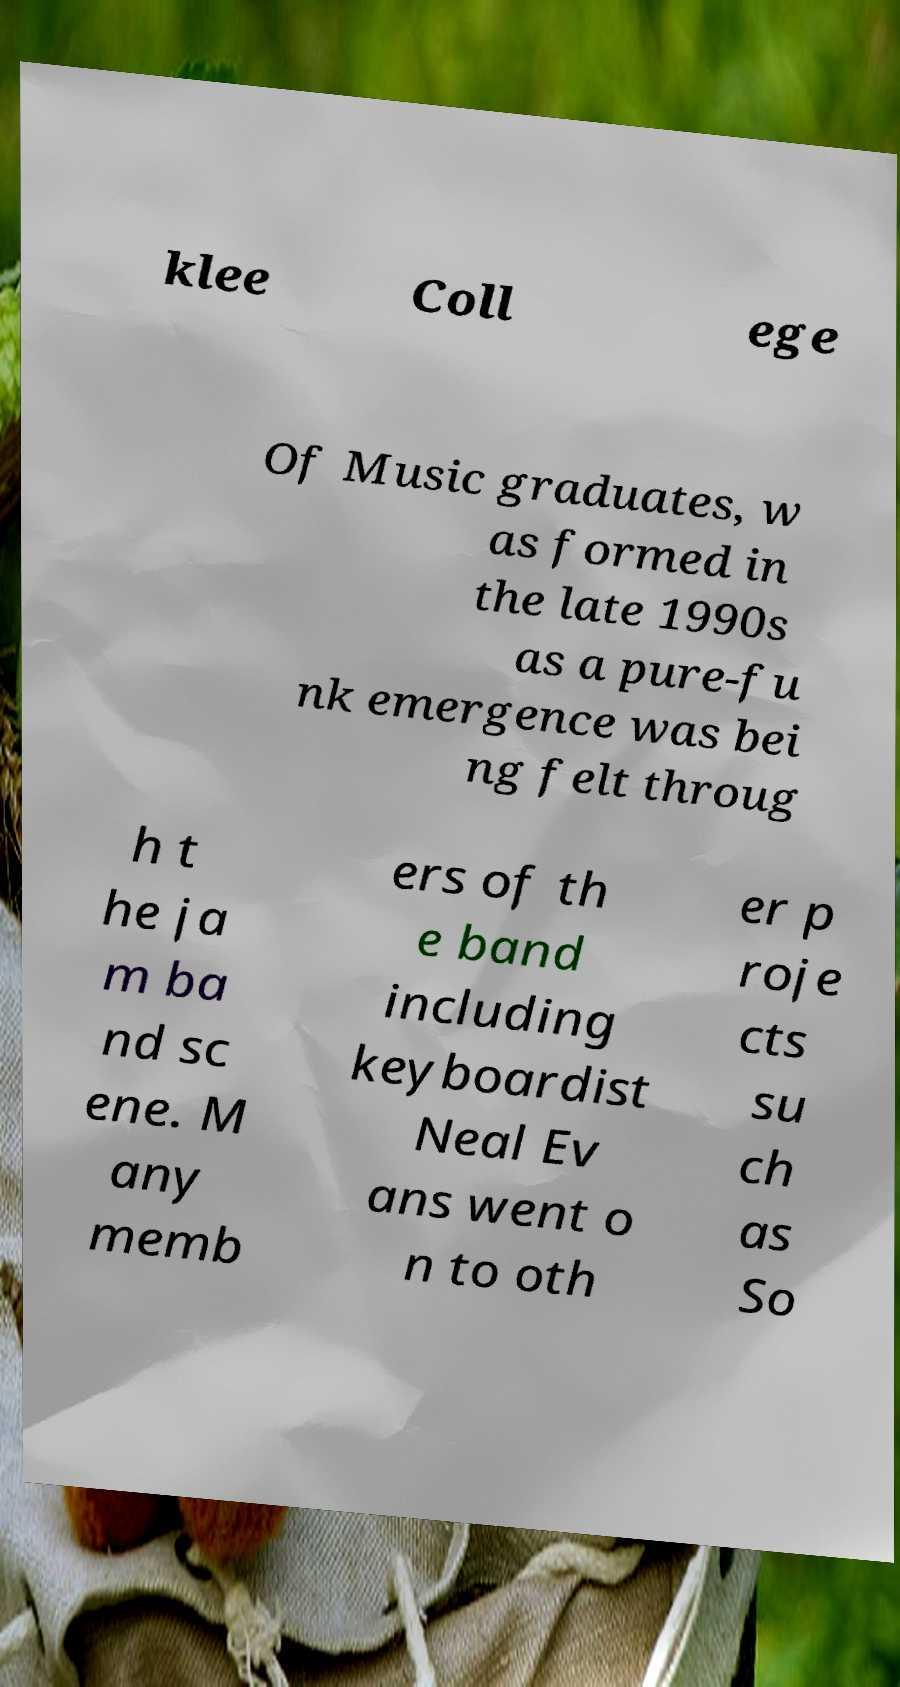I need the written content from this picture converted into text. Can you do that? klee Coll ege Of Music graduates, w as formed in the late 1990s as a pure-fu nk emergence was bei ng felt throug h t he ja m ba nd sc ene. M any memb ers of th e band including keyboardist Neal Ev ans went o n to oth er p roje cts su ch as So 